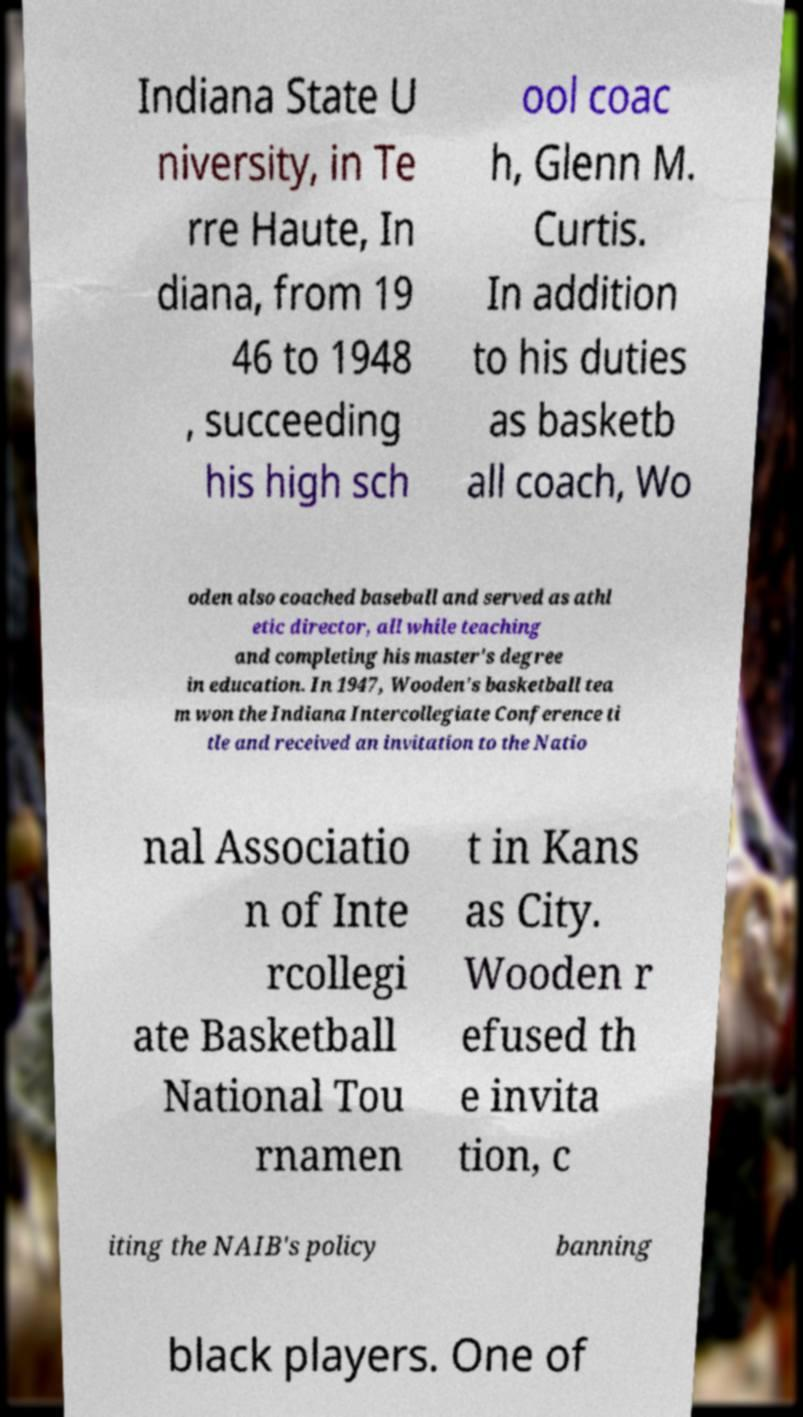I need the written content from this picture converted into text. Can you do that? Indiana State U niversity, in Te rre Haute, In diana, from 19 46 to 1948 , succeeding his high sch ool coac h, Glenn M. Curtis. In addition to his duties as basketb all coach, Wo oden also coached baseball and served as athl etic director, all while teaching and completing his master's degree in education. In 1947, Wooden's basketball tea m won the Indiana Intercollegiate Conference ti tle and received an invitation to the Natio nal Associatio n of Inte rcollegi ate Basketball National Tou rnamen t in Kans as City. Wooden r efused th e invita tion, c iting the NAIB's policy banning black players. One of 